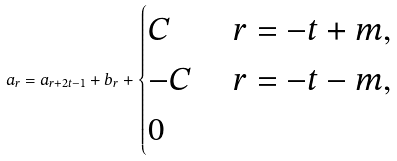<formula> <loc_0><loc_0><loc_500><loc_500>a _ { r } = a _ { r + 2 t - 1 } + b _ { r } + \begin{cases} C & \ r = - t + m , \\ - C & \ r = - t - m , \\ 0 & \end{cases}</formula> 